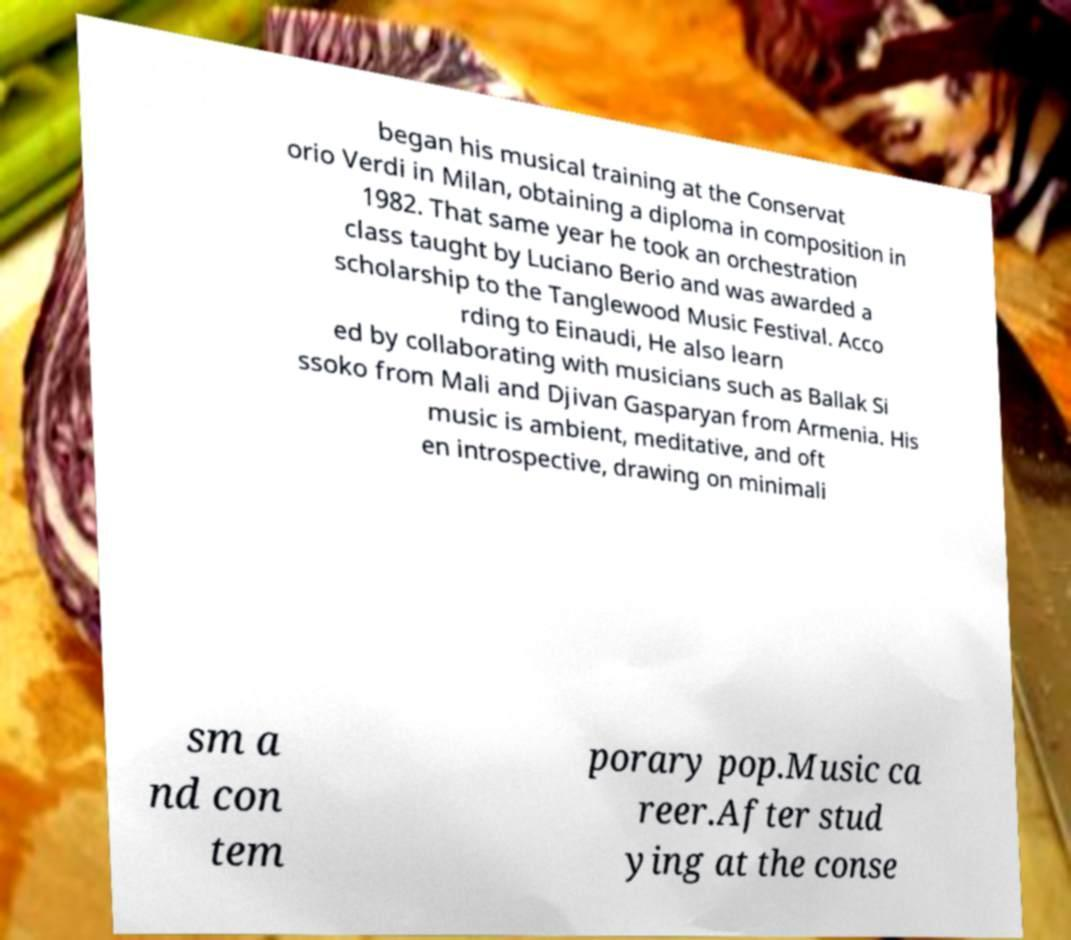Can you accurately transcribe the text from the provided image for me? began his musical training at the Conservat orio Verdi in Milan, obtaining a diploma in composition in 1982. That same year he took an orchestration class taught by Luciano Berio and was awarded a scholarship to the Tanglewood Music Festival. Acco rding to Einaudi, He also learn ed by collaborating with musicians such as Ballak Si ssoko from Mali and Djivan Gasparyan from Armenia. His music is ambient, meditative, and oft en introspective, drawing on minimali sm a nd con tem porary pop.Music ca reer.After stud ying at the conse 